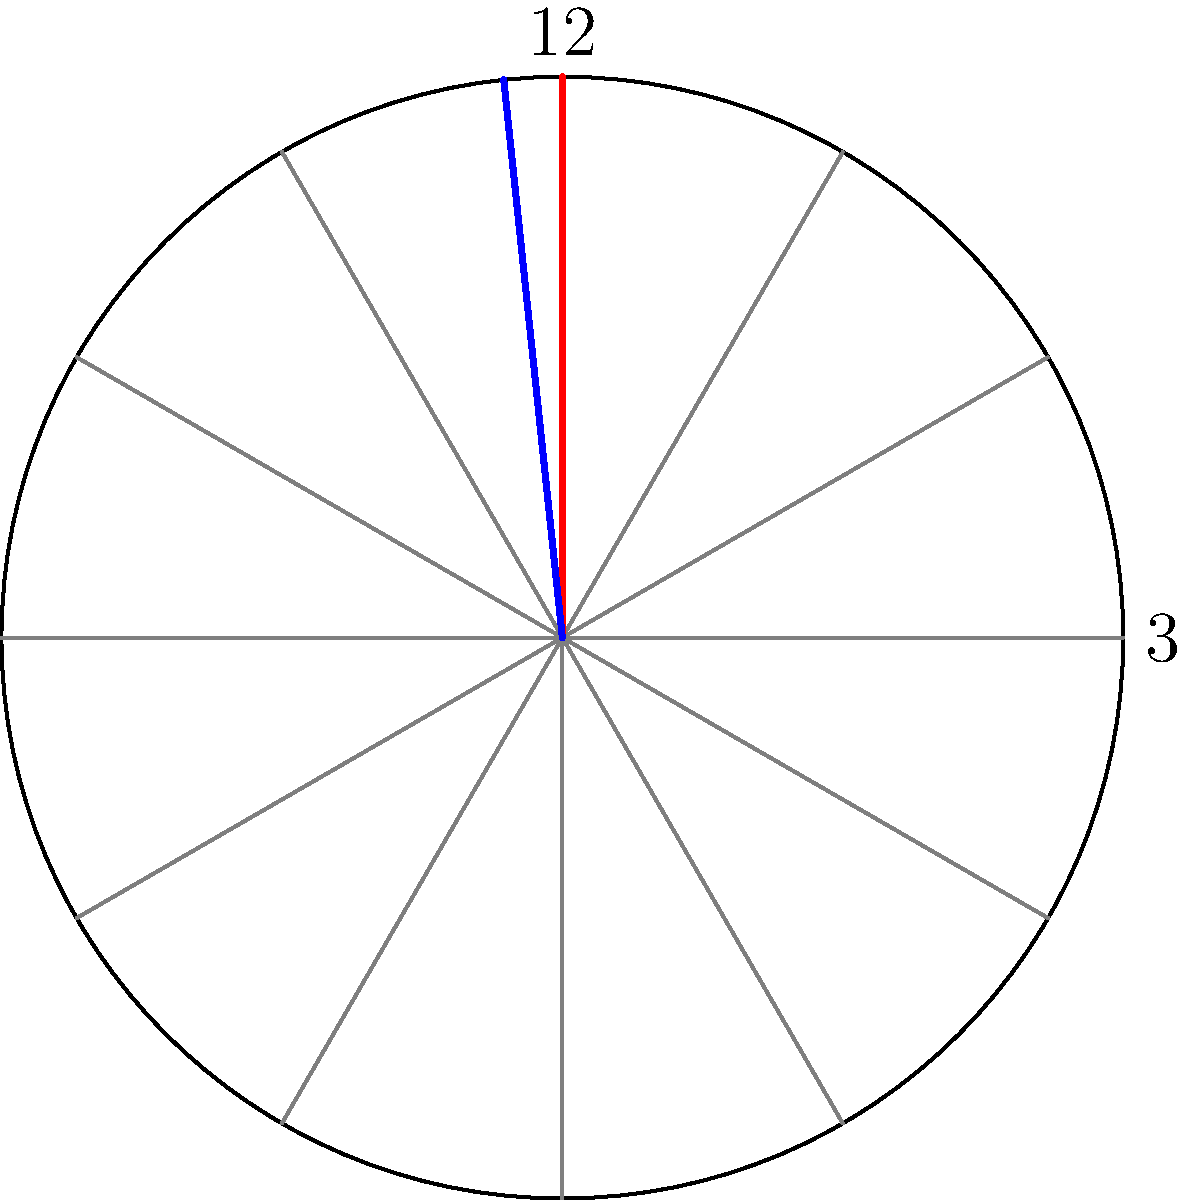Look at this picture of a clock. The red hand is the hour hand, and the blue hand is the minute hand. If it's 3:16, what's your best guess for the angle between these two hands? Let's break this down step-by-step:

1. In a clock, there are 360 degrees in a full circle.

2. For the hour hand:
   - There are 12 hours in a full rotation.
   - So, each hour represents 360° ÷ 12 = 30°.
   - At 3 o'clock, the hour hand has moved 3 × 30° = 90° from the 12 o'clock position.
   - But it's 3:16, so it's moved a bit more. In 16 minutes, it moves an additional 16 ÷ 60 × 30° = 8°.
   - So the hour hand is at about 98° from 12 o'clock.

3. For the minute hand:
   - There are 60 minutes in a full rotation.
   - So, each minute represents 360° ÷ 60 = 6°.
   - At 16 minutes past the hour, the minute hand has moved 16 × 6° = 96° from 12 o'clock.

4. To find the angle between the hands:
   - Subtract the smaller angle from the larger: 98° - 96° = 2°.

5. Therefore, the angle between the hour and minute hands at 3:16 is approximately 2°.
Answer: 2° 